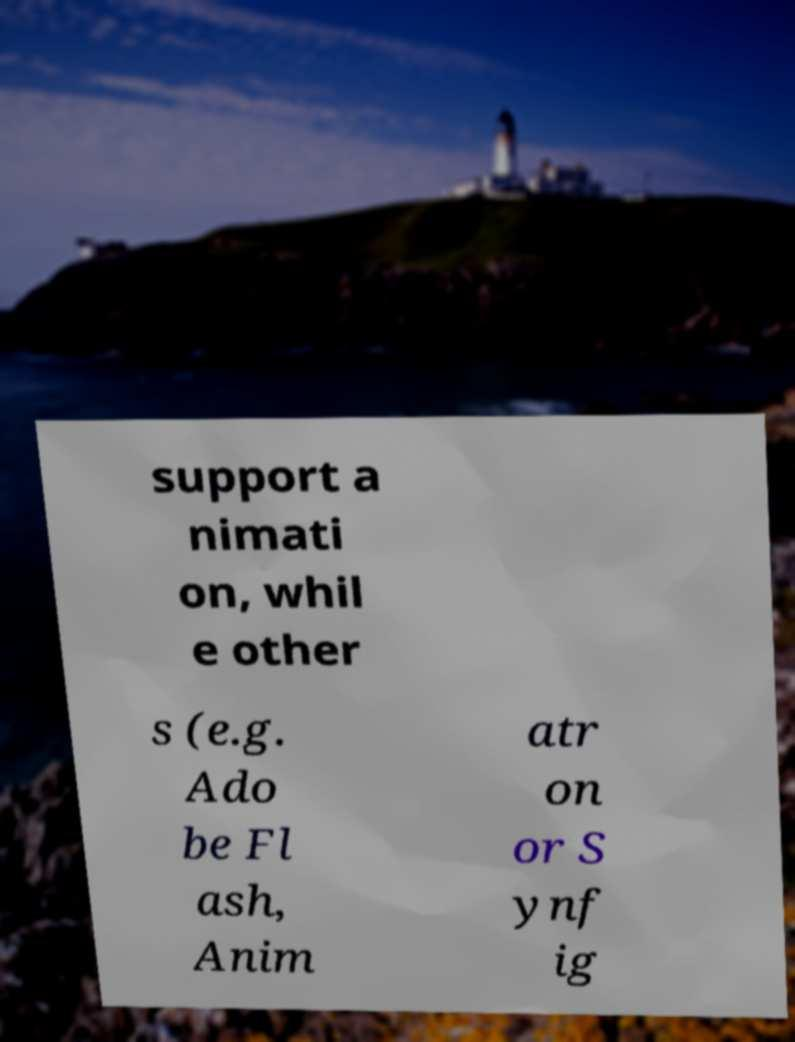I need the written content from this picture converted into text. Can you do that? support a nimati on, whil e other s (e.g. Ado be Fl ash, Anim atr on or S ynf ig 